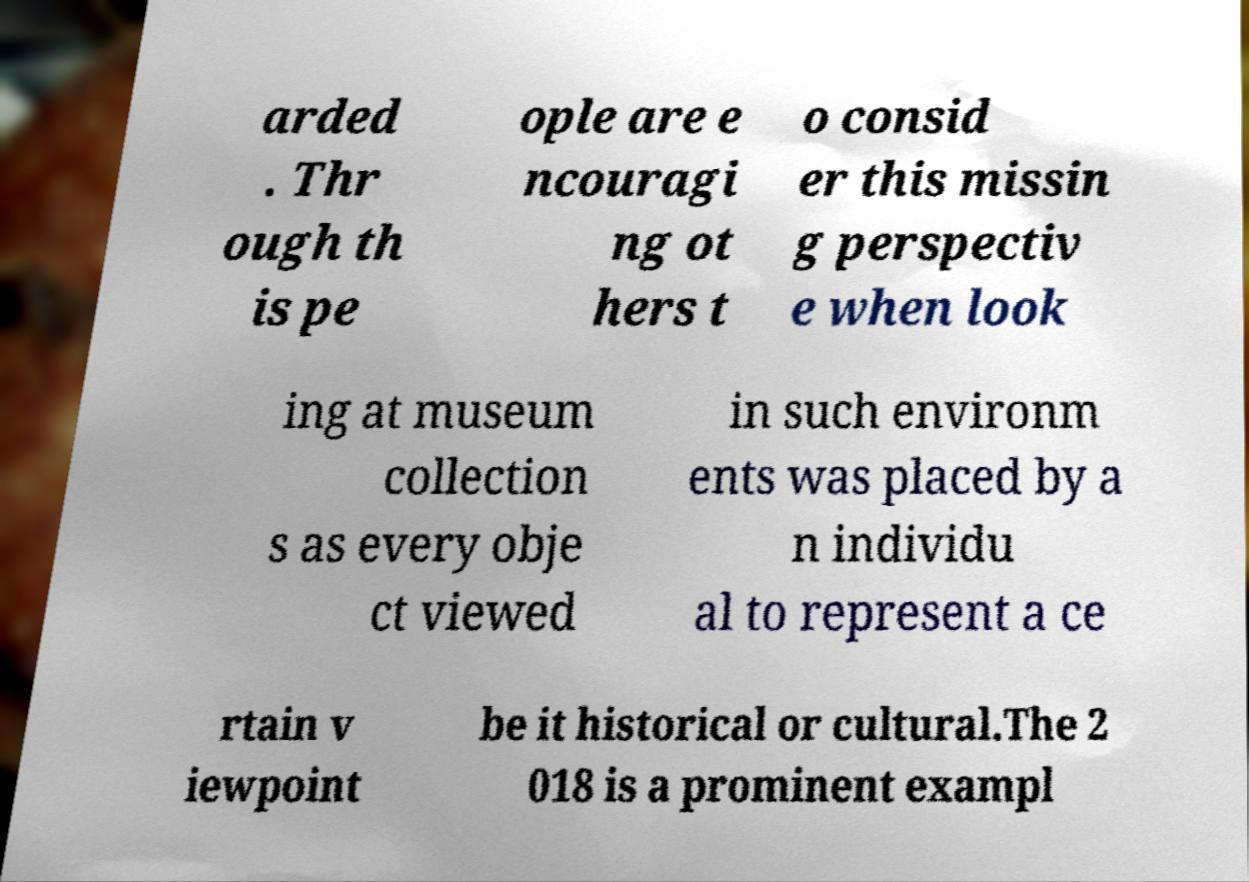There's text embedded in this image that I need extracted. Can you transcribe it verbatim? arded . Thr ough th is pe ople are e ncouragi ng ot hers t o consid er this missin g perspectiv e when look ing at museum collection s as every obje ct viewed in such environm ents was placed by a n individu al to represent a ce rtain v iewpoint be it historical or cultural.The 2 018 is a prominent exampl 